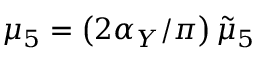<formula> <loc_0><loc_0><loc_500><loc_500>\mu _ { 5 } = \left ( 2 \alpha _ { Y } / \pi \right ) \tilde { \mu } _ { 5 }</formula> 